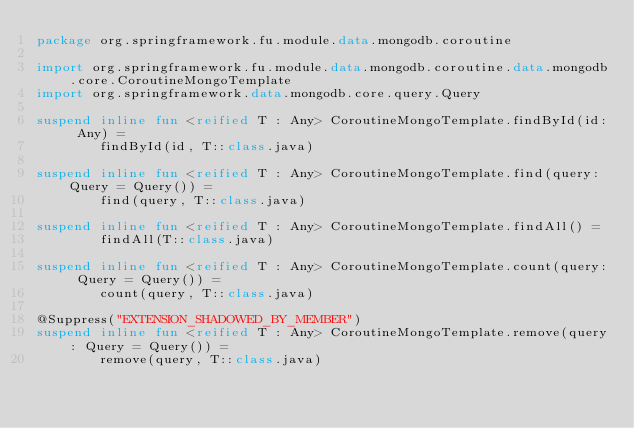<code> <loc_0><loc_0><loc_500><loc_500><_Kotlin_>package org.springframework.fu.module.data.mongodb.coroutine

import org.springframework.fu.module.data.mongodb.coroutine.data.mongodb.core.CoroutineMongoTemplate
import org.springframework.data.mongodb.core.query.Query

suspend inline fun <reified T : Any> CoroutineMongoTemplate.findById(id: Any) =
		findById(id, T::class.java)

suspend inline fun <reified T : Any> CoroutineMongoTemplate.find(query: Query = Query()) =
		find(query, T::class.java)

suspend inline fun <reified T : Any> CoroutineMongoTemplate.findAll() =
		findAll(T::class.java)

suspend inline fun <reified T : Any> CoroutineMongoTemplate.count(query: Query = Query()) =
		count(query, T::class.java)

@Suppress("EXTENSION_SHADOWED_BY_MEMBER")
suspend inline fun <reified T : Any> CoroutineMongoTemplate.remove(query: Query = Query()) =
		remove(query, T::class.java)</code> 